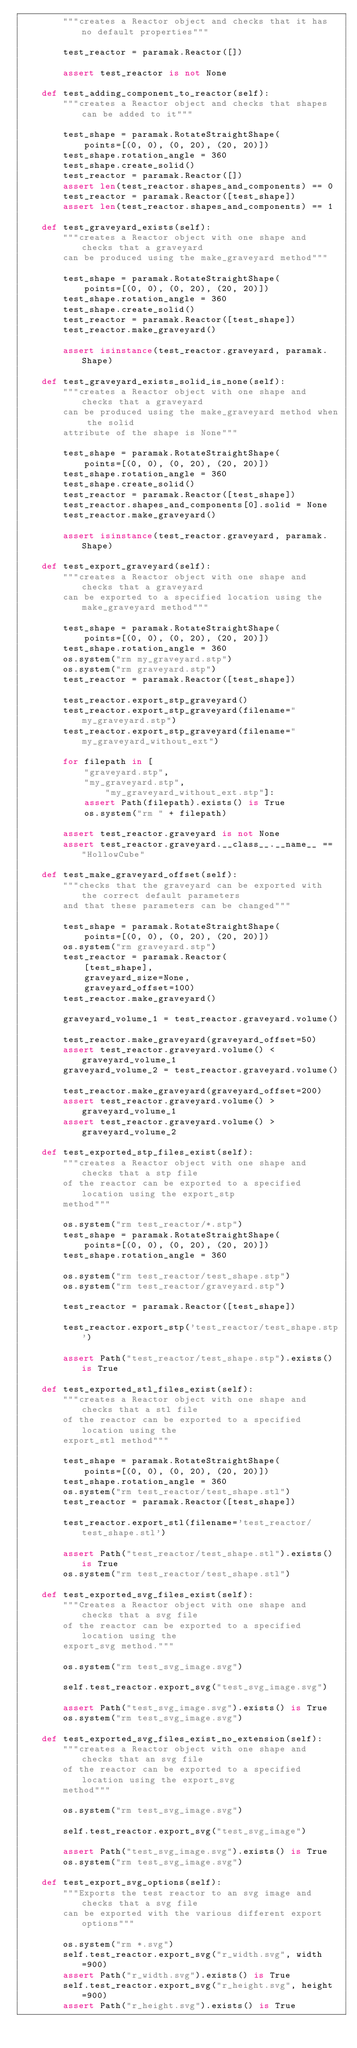Convert code to text. <code><loc_0><loc_0><loc_500><loc_500><_Python_>        """creates a Reactor object and checks that it has no default properties"""

        test_reactor = paramak.Reactor([])

        assert test_reactor is not None

    def test_adding_component_to_reactor(self):
        """creates a Reactor object and checks that shapes can be added to it"""

        test_shape = paramak.RotateStraightShape(
            points=[(0, 0), (0, 20), (20, 20)])
        test_shape.rotation_angle = 360
        test_shape.create_solid()
        test_reactor = paramak.Reactor([])
        assert len(test_reactor.shapes_and_components) == 0
        test_reactor = paramak.Reactor([test_shape])
        assert len(test_reactor.shapes_and_components) == 1

    def test_graveyard_exists(self):
        """creates a Reactor object with one shape and checks that a graveyard
        can be produced using the make_graveyard method"""

        test_shape = paramak.RotateStraightShape(
            points=[(0, 0), (0, 20), (20, 20)])
        test_shape.rotation_angle = 360
        test_shape.create_solid()
        test_reactor = paramak.Reactor([test_shape])
        test_reactor.make_graveyard()

        assert isinstance(test_reactor.graveyard, paramak.Shape)

    def test_graveyard_exists_solid_is_none(self):
        """creates a Reactor object with one shape and checks that a graveyard
        can be produced using the make_graveyard method when the solid
        attribute of the shape is None"""

        test_shape = paramak.RotateStraightShape(
            points=[(0, 0), (0, 20), (20, 20)])
        test_shape.rotation_angle = 360
        test_shape.create_solid()
        test_reactor = paramak.Reactor([test_shape])
        test_reactor.shapes_and_components[0].solid = None
        test_reactor.make_graveyard()

        assert isinstance(test_reactor.graveyard, paramak.Shape)

    def test_export_graveyard(self):
        """creates a Reactor object with one shape and checks that a graveyard
        can be exported to a specified location using the make_graveyard method"""

        test_shape = paramak.RotateStraightShape(
            points=[(0, 0), (0, 20), (20, 20)])
        test_shape.rotation_angle = 360
        os.system("rm my_graveyard.stp")
        os.system("rm graveyard.stp")
        test_reactor = paramak.Reactor([test_shape])

        test_reactor.export_stp_graveyard()
        test_reactor.export_stp_graveyard(filename="my_graveyard.stp")
        test_reactor.export_stp_graveyard(filename="my_graveyard_without_ext")

        for filepath in [
            "graveyard.stp",
            "my_graveyard.stp",
                "my_graveyard_without_ext.stp"]:
            assert Path(filepath).exists() is True
            os.system("rm " + filepath)

        assert test_reactor.graveyard is not None
        assert test_reactor.graveyard.__class__.__name__ == "HollowCube"

    def test_make_graveyard_offset(self):
        """checks that the graveyard can be exported with the correct default parameters
        and that these parameters can be changed"""

        test_shape = paramak.RotateStraightShape(
            points=[(0, 0), (0, 20), (20, 20)])
        os.system("rm graveyard.stp")
        test_reactor = paramak.Reactor(
            [test_shape],
            graveyard_size=None,
            graveyard_offset=100)
        test_reactor.make_graveyard()

        graveyard_volume_1 = test_reactor.graveyard.volume()

        test_reactor.make_graveyard(graveyard_offset=50)
        assert test_reactor.graveyard.volume() < graveyard_volume_1
        graveyard_volume_2 = test_reactor.graveyard.volume()

        test_reactor.make_graveyard(graveyard_offset=200)
        assert test_reactor.graveyard.volume() > graveyard_volume_1
        assert test_reactor.graveyard.volume() > graveyard_volume_2

    def test_exported_stp_files_exist(self):
        """creates a Reactor object with one shape and checks that a stp file
        of the reactor can be exported to a specified location using the export_stp
        method"""

        os.system("rm test_reactor/*.stp")
        test_shape = paramak.RotateStraightShape(
            points=[(0, 0), (0, 20), (20, 20)])
        test_shape.rotation_angle = 360

        os.system("rm test_reactor/test_shape.stp")
        os.system("rm test_reactor/graveyard.stp")

        test_reactor = paramak.Reactor([test_shape])

        test_reactor.export_stp('test_reactor/test_shape.stp')

        assert Path("test_reactor/test_shape.stp").exists() is True

    def test_exported_stl_files_exist(self):
        """creates a Reactor object with one shape and checks that a stl file
        of the reactor can be exported to a specified location using the
        export_stl method"""

        test_shape = paramak.RotateStraightShape(
            points=[(0, 0), (0, 20), (20, 20)])
        test_shape.rotation_angle = 360
        os.system("rm test_reactor/test_shape.stl")
        test_reactor = paramak.Reactor([test_shape])

        test_reactor.export_stl(filename='test_reactor/test_shape.stl')

        assert Path("test_reactor/test_shape.stl").exists() is True
        os.system("rm test_reactor/test_shape.stl")

    def test_exported_svg_files_exist(self):
        """Creates a Reactor object with one shape and checks that a svg file
        of the reactor can be exported to a specified location using the
        export_svg method."""

        os.system("rm test_svg_image.svg")

        self.test_reactor.export_svg("test_svg_image.svg")

        assert Path("test_svg_image.svg").exists() is True
        os.system("rm test_svg_image.svg")

    def test_exported_svg_files_exist_no_extension(self):
        """creates a Reactor object with one shape and checks that an svg file
        of the reactor can be exported to a specified location using the export_svg
        method"""

        os.system("rm test_svg_image.svg")

        self.test_reactor.export_svg("test_svg_image")

        assert Path("test_svg_image.svg").exists() is True
        os.system("rm test_svg_image.svg")

    def test_export_svg_options(self):
        """Exports the test reactor to an svg image and checks that a svg file
        can be exported with the various different export options"""

        os.system("rm *.svg")
        self.test_reactor.export_svg("r_width.svg", width=900)
        assert Path("r_width.svg").exists() is True
        self.test_reactor.export_svg("r_height.svg", height=900)
        assert Path("r_height.svg").exists() is True</code> 